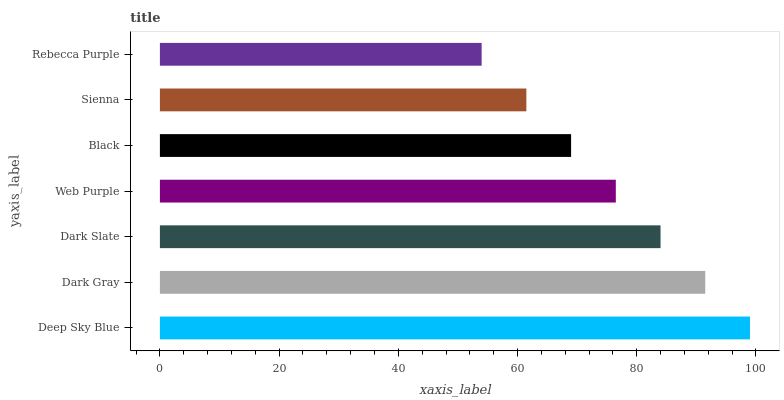Is Rebecca Purple the minimum?
Answer yes or no. Yes. Is Deep Sky Blue the maximum?
Answer yes or no. Yes. Is Dark Gray the minimum?
Answer yes or no. No. Is Dark Gray the maximum?
Answer yes or no. No. Is Deep Sky Blue greater than Dark Gray?
Answer yes or no. Yes. Is Dark Gray less than Deep Sky Blue?
Answer yes or no. Yes. Is Dark Gray greater than Deep Sky Blue?
Answer yes or no. No. Is Deep Sky Blue less than Dark Gray?
Answer yes or no. No. Is Web Purple the high median?
Answer yes or no. Yes. Is Web Purple the low median?
Answer yes or no. Yes. Is Rebecca Purple the high median?
Answer yes or no. No. Is Black the low median?
Answer yes or no. No. 